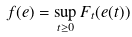Convert formula to latex. <formula><loc_0><loc_0><loc_500><loc_500>f ( e ) = \sup _ { t \geq 0 } F _ { t } ( e ( t ) )</formula> 